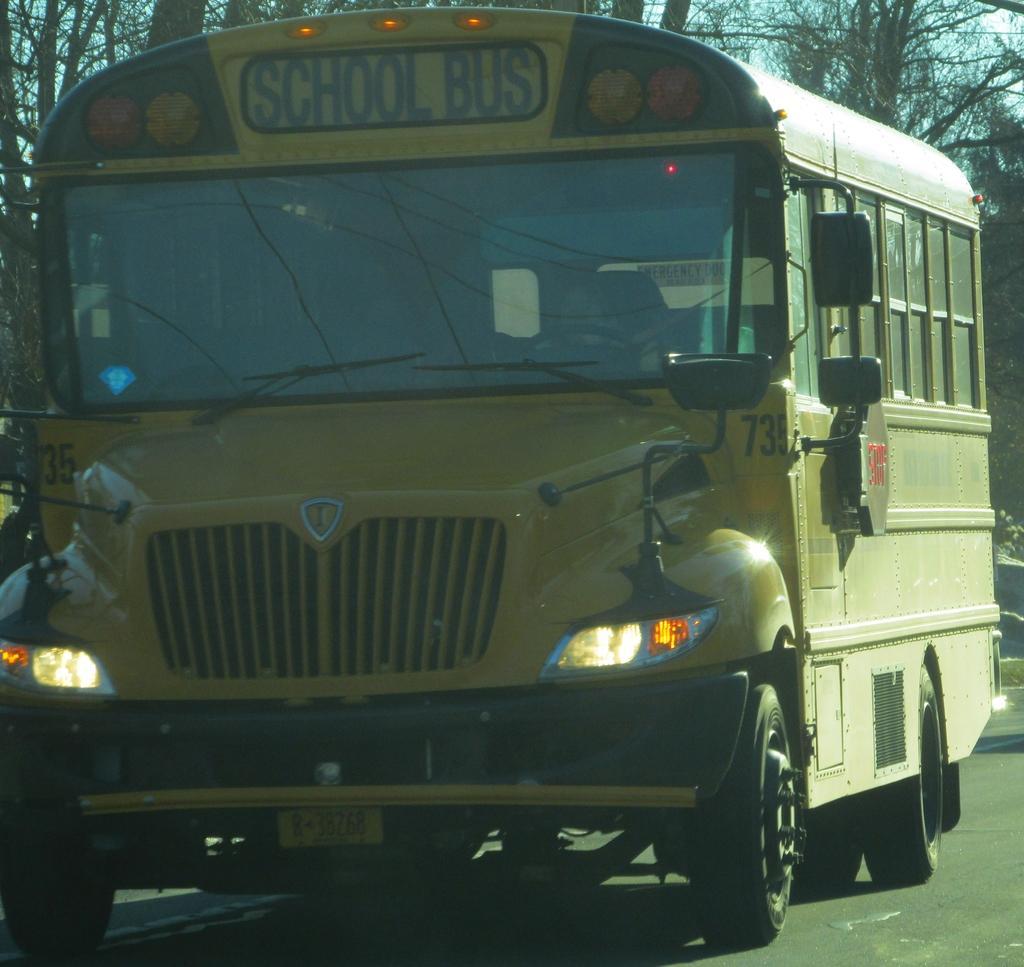Describe this image in one or two sentences. There is a bus having lights and glass windows on a road. In the background, there are trees and there is sky. 